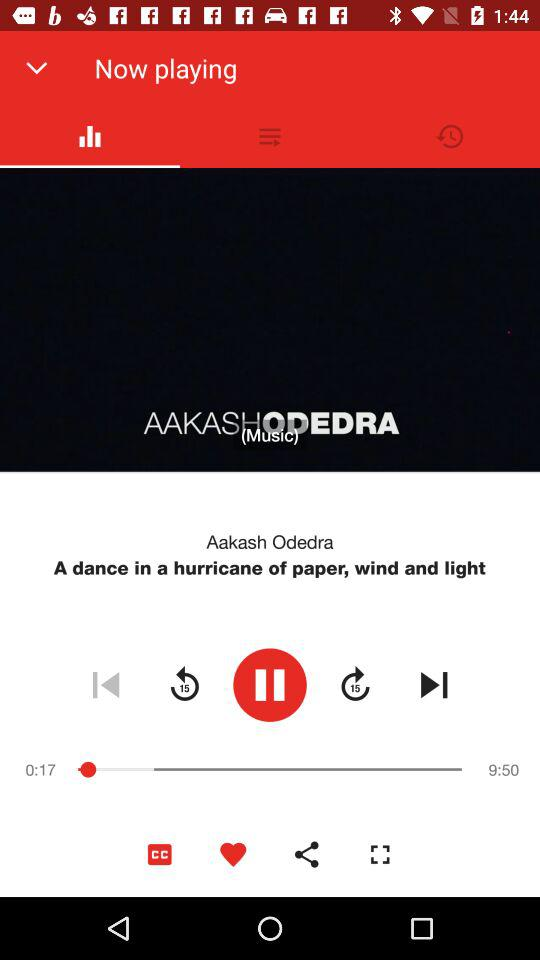What is the song's duration? The duration of the song is 9 minutes and 50 seconds. 